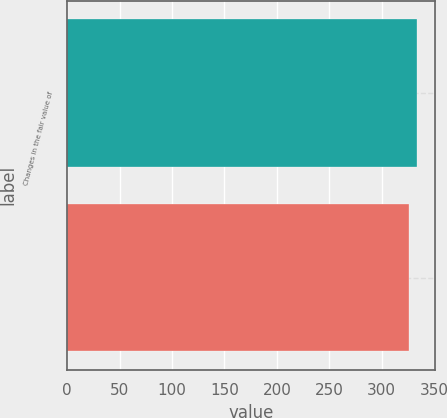Convert chart. <chart><loc_0><loc_0><loc_500><loc_500><bar_chart><fcel>Changes in the fair value of<fcel>Unnamed: 1<nl><fcel>334<fcel>326<nl></chart> 